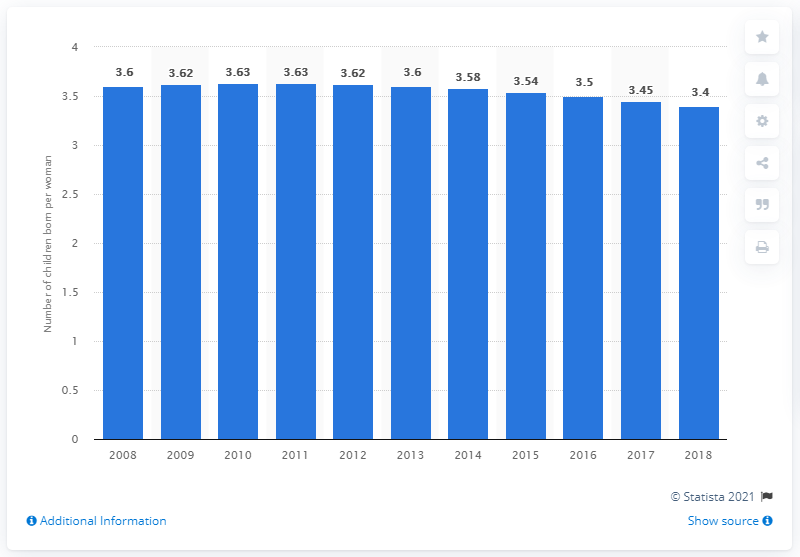Specify some key components in this picture. In 2018, the fertility rate in Namibia was 3.4. 